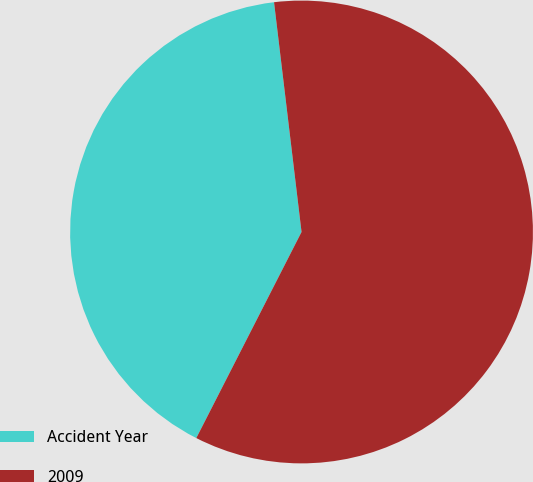Convert chart. <chart><loc_0><loc_0><loc_500><loc_500><pie_chart><fcel>Accident Year<fcel>2009<nl><fcel>40.59%<fcel>59.41%<nl></chart> 